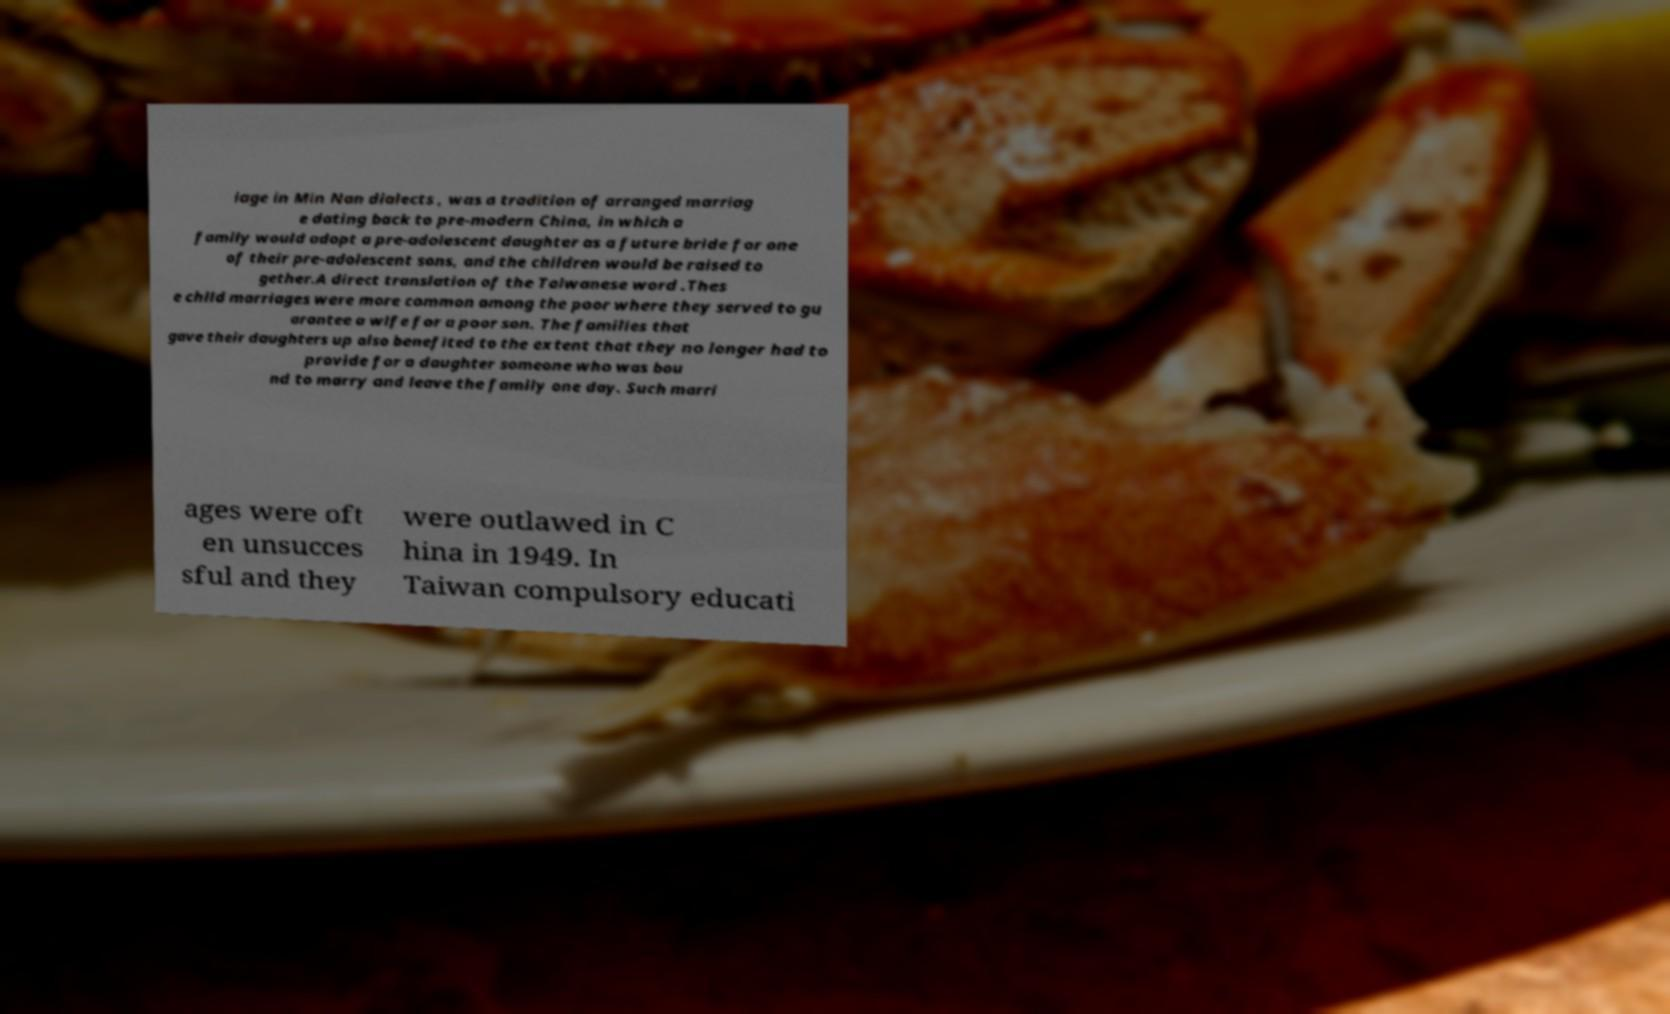Can you read and provide the text displayed in the image?This photo seems to have some interesting text. Can you extract and type it out for me? iage in Min Nan dialects , was a tradition of arranged marriag e dating back to pre-modern China, in which a family would adopt a pre-adolescent daughter as a future bride for one of their pre-adolescent sons, and the children would be raised to gether.A direct translation of the Taiwanese word .Thes e child marriages were more common among the poor where they served to gu arantee a wife for a poor son. The families that gave their daughters up also benefited to the extent that they no longer had to provide for a daughter someone who was bou nd to marry and leave the family one day. Such marri ages were oft en unsucces sful and they were outlawed in C hina in 1949. In Taiwan compulsory educati 